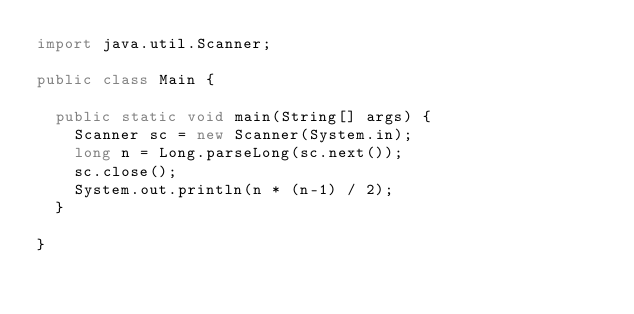Convert code to text. <code><loc_0><loc_0><loc_500><loc_500><_Java_>import java.util.Scanner;

public class Main {

	public static void main(String[] args) {
		Scanner sc = new Scanner(System.in);
		long n = Long.parseLong(sc.next());
		sc.close();
		System.out.println(n * (n-1) / 2);
	}

}</code> 